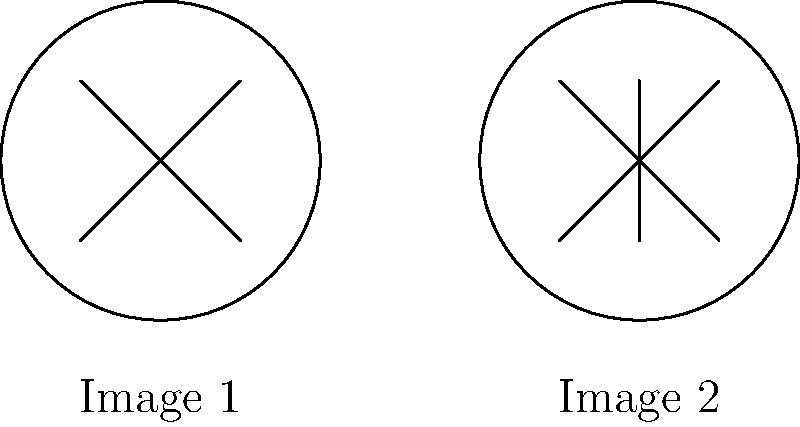Look at the two cartoon faces. Can you spot the difference between Image 1 and Image 2? Let's compare the two images step by step:

1. Both images have a circle for the face outline.
2. Both images have two diagonal lines forming an "X" shape inside the circle.
3. The main difference is in Image 2:
   - There is an additional vertical line in the center of the face.
   - This vertical line goes from the top of the "X" to the bottom of the "X".
4. Image 1 does not have this vertical line.

The vertical line in Image 2 makes it look like the face has a nose, while Image 1 doesn't have this feature.
Answer: Image 2 has an extra vertical line (nose) in the center. 